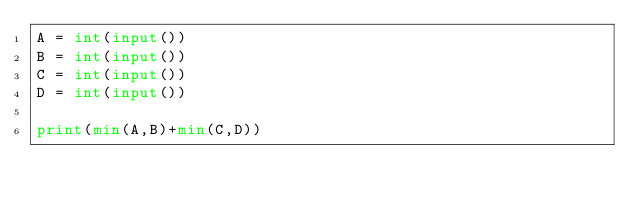<code> <loc_0><loc_0><loc_500><loc_500><_Python_>A = int(input())
B = int(input())
C = int(input())
D = int(input())

print(min(A,B)+min(C,D))</code> 